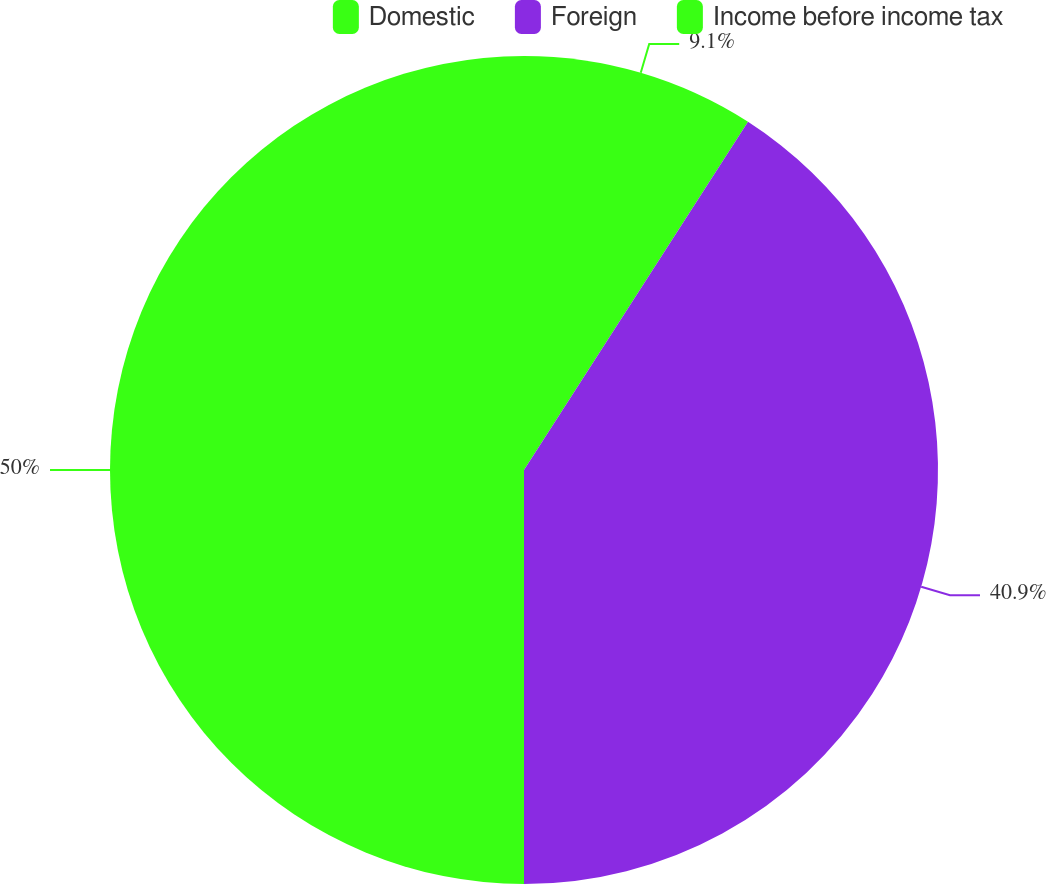Convert chart. <chart><loc_0><loc_0><loc_500><loc_500><pie_chart><fcel>Domestic<fcel>Foreign<fcel>Income before income tax<nl><fcel>9.1%<fcel>40.9%<fcel>50.0%<nl></chart> 